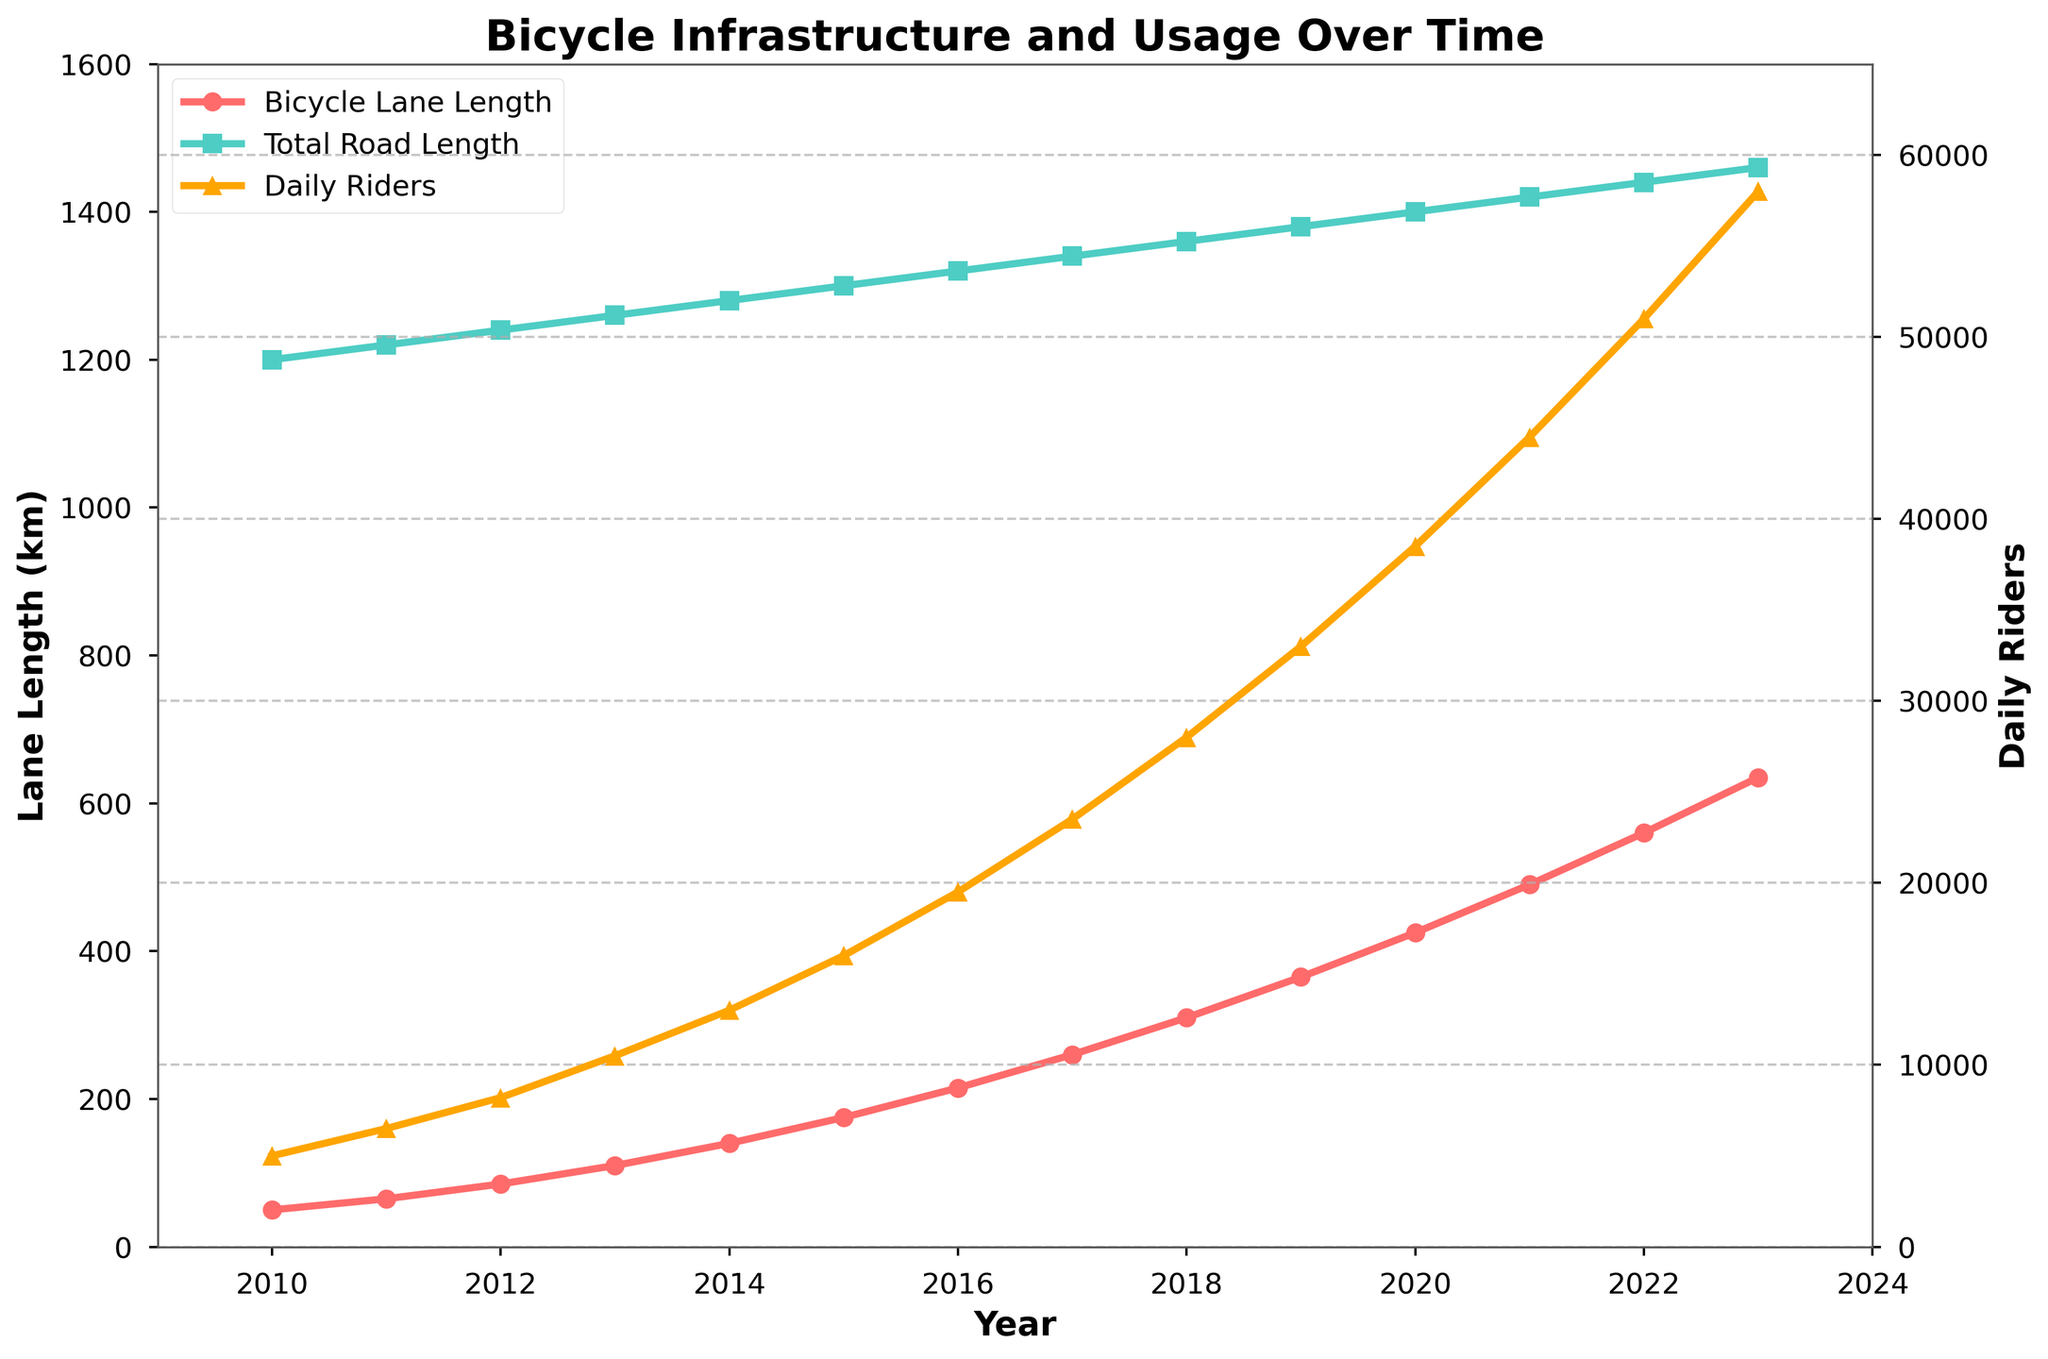What is the total length of bicycle lanes added between 2010 and 2023? Subtract the bicycle lane length in 2010 from the length in 2023. The length in 2010 is 50 km and in 2023 is 635 km. So, 635 - 50 = 585 km.
Answer: 585 km When did the bicycle lane length surpass 200 km? Look at the bicycle lane length over the years and find when it first exceeds 200 km. In 2016, the length is 215 km which is the first instance above 200 km.
Answer: 2016 By how much did daily riders increase from 2018 to 2020? Subtract the daily riders in 2018 from the riders in 2020. The number in 2018 is 28000 and in 2020 is 38500. So, 38500 - 28000 = 10500.
Answer: 10500 Which year had a greater increase in bicycle lane length, 2015 or 2016? Calculate the difference in bicycle lane length year over year. From 2014 to 2015: 175 - 140 = 35 km. From 2015 to 2016: 215 - 175 = 40 km. Therefore, 2016 had a greater increase.
Answer: 2016 Is the rate of increase in daily riders faster from 2010 to 2015 or from 2015 to 2020? Calculate the increase in daily riders and the number of years for both periods. From 2010 to 2015: 16000 - 5000 = 11000 over 5 years = 2200/year. From 2015 to 2020: 38500 - 16000 = 22500 over 5 years = 4500/year. The rate from 2015 to 2020 is faster.
Answer: 2015 to 2020 How does the growth of bicycle lanes compare to the total road length between 2010 and 2023? Compare the increase in bicycle lane length and total road length. Bicycle lanes increased from 50 km in 2010 to 635 km in 2023 (585 km increase), whereas total road length increased from 1200 km to 1460 km (260 km increase). Bicycle lane length grew more significantly.
Answer: Bicycle lanes grew more significantly What visual elements indicate the trend of daily riders over the years? The line representing daily riders is plotted in orange and it shows an upward trajectory from 2010 to 2023, indicating an increasing trend in daily riders.
Answer: Upward trajectory What year saw the largest annual increase in bicycle lane length? Inspect the annual changes in bicycle lane length. From 2019 to 2020, the length increased from 365 km to 425 km, which is an increase of 60 km, the largest observed.
Answer: 2019 to 2020 By what factor has the daily ridership increased from 2010 to 2023? Divide the value of daily riders in 2023 by the value in 2010. Daily riders in 2023 are 58000 and in 2010 are 5000. So, 58000 / 5000 = 11.6.
Answer: 11.6 Is there a visual correlation between the growth of bicycle lane length and the increase in daily riders? Both lines, one representing bicycle lane length (in red) and the other representing daily riders (in orange), show a parallel upward trend over the years, indicating a positive correlation.
Answer: Positive correlation 